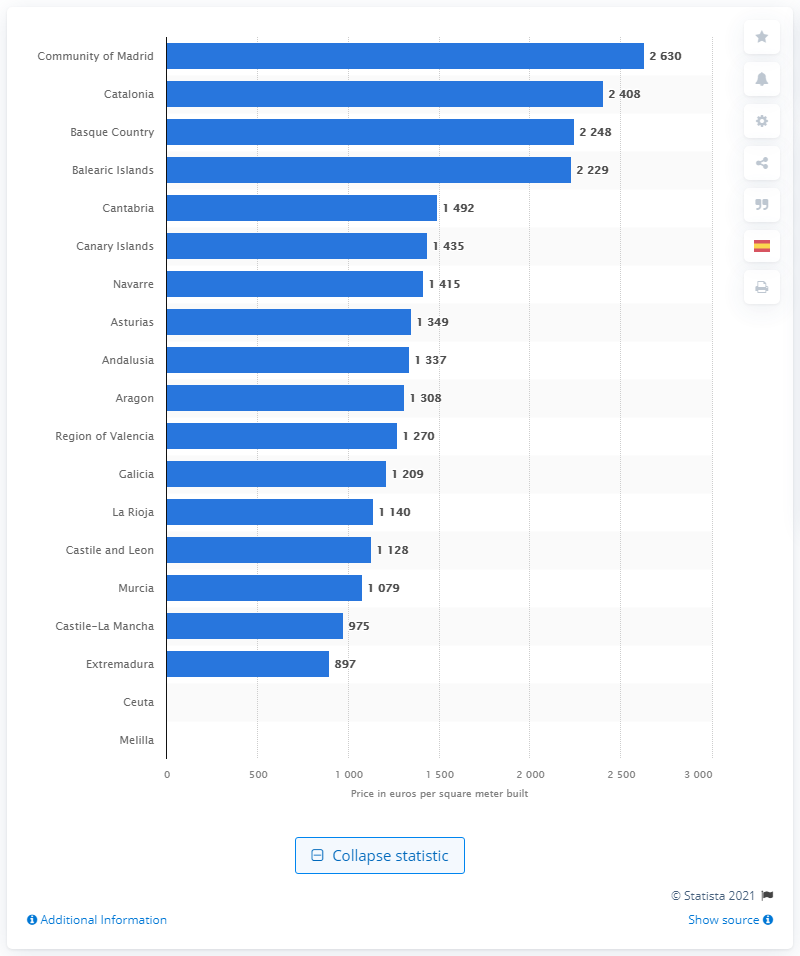Draw attention to some important aspects in this diagram. The average property price in Catalonia as of October 2020 was 2,408. 